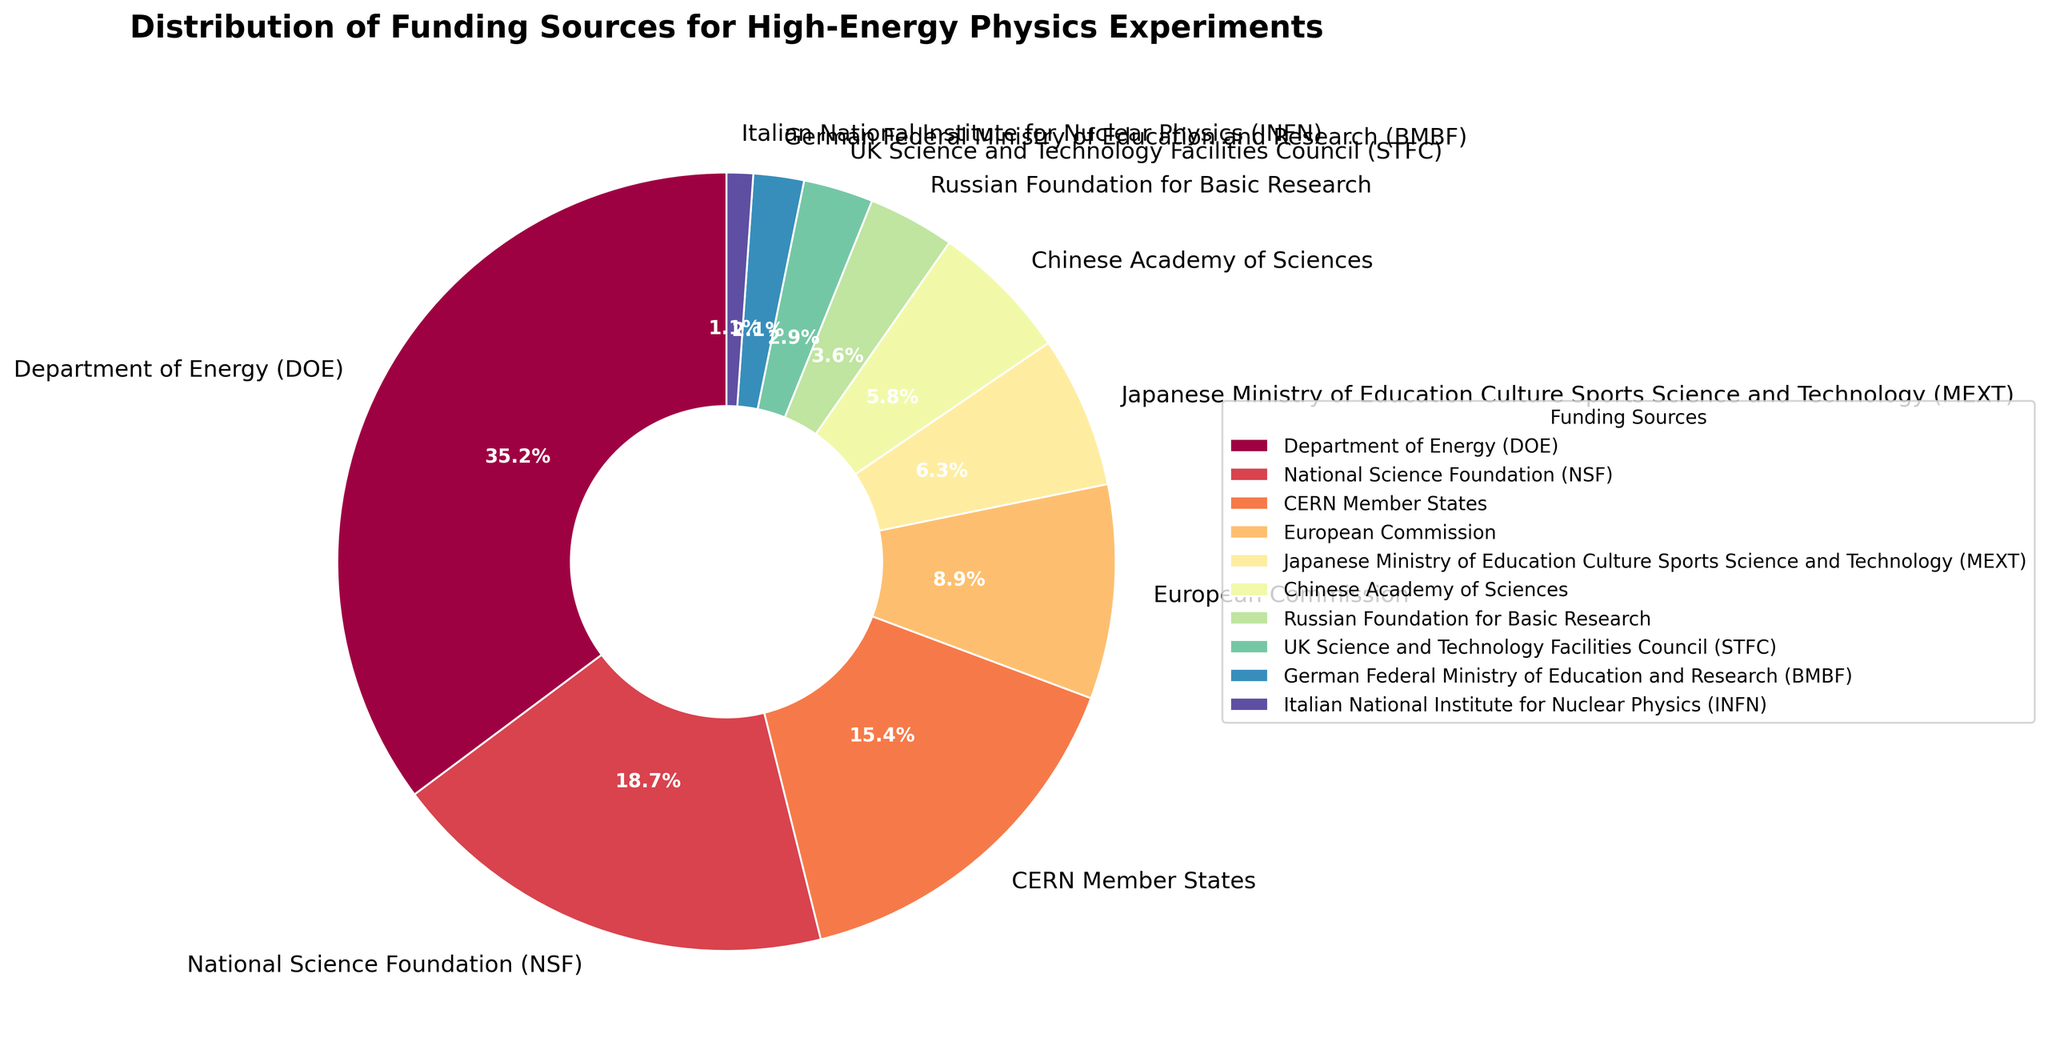What are the top three funding sources by percentage? Looking at the pie chart, the three sectors with the largest slices are 1) Department of Energy (DOE) at 35.2%, 2) National Science Foundation (NSF) at 18.7%, and 3) CERN Member States at 15.4%.
Answer: Department of Energy (DOE), National Science Foundation (NSF), CERN Member States What is the combined percentage of the top three funding sources? From the top three funding sources shown in the pie chart (DOE, NSF, CERN Member States), their individual percentages are 35.2%, 18.7%, and 15.4%. Adding these up: 35.2 + 18.7 + 15.4 = 69.3%.
Answer: 69.3% Which funding source provides the least percentage? Observing the smallest slice in the pie chart reveals that the Italian National Institute for Nuclear Physics (INFN) has the lowest percentage, listed at 1.1%.
Answer: Italian National Institute for Nuclear Physics (INFN) How much more does the Department of Energy (DOE) contribute compared to the European Commission? The DOE contributes 35.2%, and the European Commission contributes 8.9%. The difference is calculated as 35.2 - 8.9 = 26.3%.
Answer: 26.3% Which two funding sources have a combined contribution of more than 20% but less than 25%? By examining the pie chart, potential pairs include the Japanese Ministry of Education Culture Sports Science and Technology (MEXT) with 6.3% and the Chinese Academy of Sciences with 5.8% which, combined, yield 6.3 + 5.8 = 12.1%, which is less than 20%. Another potential pair is CERN Member States (15.4%) and any lower percentage. However, when adding National Science Foundation (NSF) 18.7% and Russian Foundation for Basic Research 3.6%, it results in 18.7 + 3.6 = 22.3%, which lies within the defined range.
Answer: National Science Foundation (NSF) and Russian Foundation for Basic Research What is the average percentage contribution of the UK Science and Technology Facilities Council (STFC) and the German Federal Ministry of Education and Research (BMBF)? STFC contributes 2.9%, and BMBF contributes 2.1%. Their average combined percentage is calculated as (2.9 + 2.1) / 2 = 2.5%.
Answer: 2.5% How does the funding percentage from NSF compare to that from CERN Member States? The NSF has a percentage of 18.7%, while CERN Member States have 15.4%. Therefore, NSF contributes a larger percentage.
Answer: NSF contributes more What is the difference in funding percentage between the highest and the lowest contributors? The highest percentage is from the DOE at 35.2%, and the lowest is from INFN at 1.1%. The difference is calculated as 35.2 - 1.1 = 34.1%.
Answer: 34.1% Which funding source contributes slightly less than 5%? Observing the pie chart labels, the funding source that contributes slightly less than 5% is the Chinese Academy of Sciences, contributing 5.8%. Hence slight modification might be noticed but within the visible range which falls under options near 6% or 5%. However the target near would be Russian Foundation with 3.6%.
Answer: Russian Foundation for Basic Research What proportion of the total funding comes from European organizations (CERN Member States and European Commission)? Adding the percentages from CERN Member States (15.4%) and European Commission (8.9%) gives: 15.4 + 8.9 = 24.3%.
Answer: 24.3% 